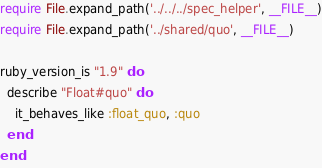<code> <loc_0><loc_0><loc_500><loc_500><_Ruby_>require File.expand_path('../../../spec_helper', __FILE__)
require File.expand_path('../shared/quo', __FILE__)

ruby_version_is "1.9" do
  describe "Float#quo" do
    it_behaves_like :float_quo, :quo
  end
end
</code> 